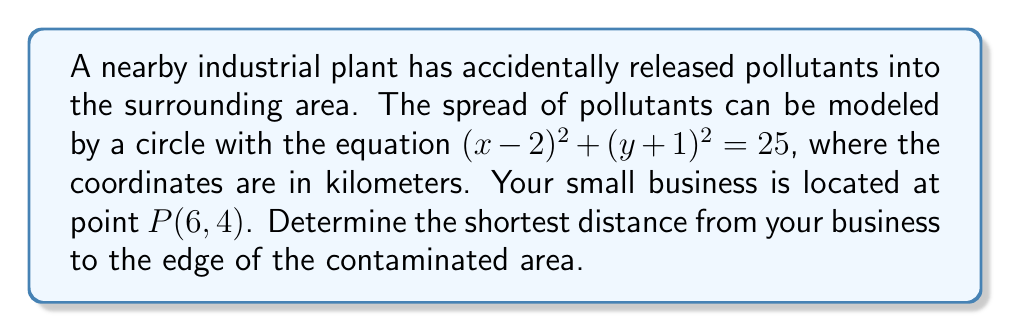Help me with this question. Let's approach this step-by-step:

1) The circle equation represents the boundary of the contaminated area:
   $$(x-2)^2 + (y+1)^2 = 25$$

2) The center of this circle is at (2, -1), and its radius is 5 km (since $5^2 = 25$).

3) To find the shortest distance from point P to the circle, we need to find the length of the tangent line from P to the circle.

4) The general formula for the distance (d) from a point $(x_0, y_0)$ to a circle $(x-h)^2 + (y-k)^2 = r^2$ is:

   $$d = \sqrt{(x_0-h)^2 + (y_0-k)^2} - r$$

5) In our case:
   $(x_0, y_0) = (6, 4)$ (the location of your business)
   $(h, k) = (2, -1)$ (the center of the circle)
   $r = 5$ (the radius of the circle)

6) Plugging these values into the formula:

   $$d = \sqrt{(6-2)^2 + (4-(-1))^2} - 5$$

7) Simplifying:
   $$d = \sqrt{4^2 + 5^2} - 5$$
   $$d = \sqrt{16 + 25} - 5$$
   $$d = \sqrt{41} - 5$$

8) This gives us the shortest distance from your business to the edge of the contaminated area.
Answer: $\sqrt{41} - 5$ km 